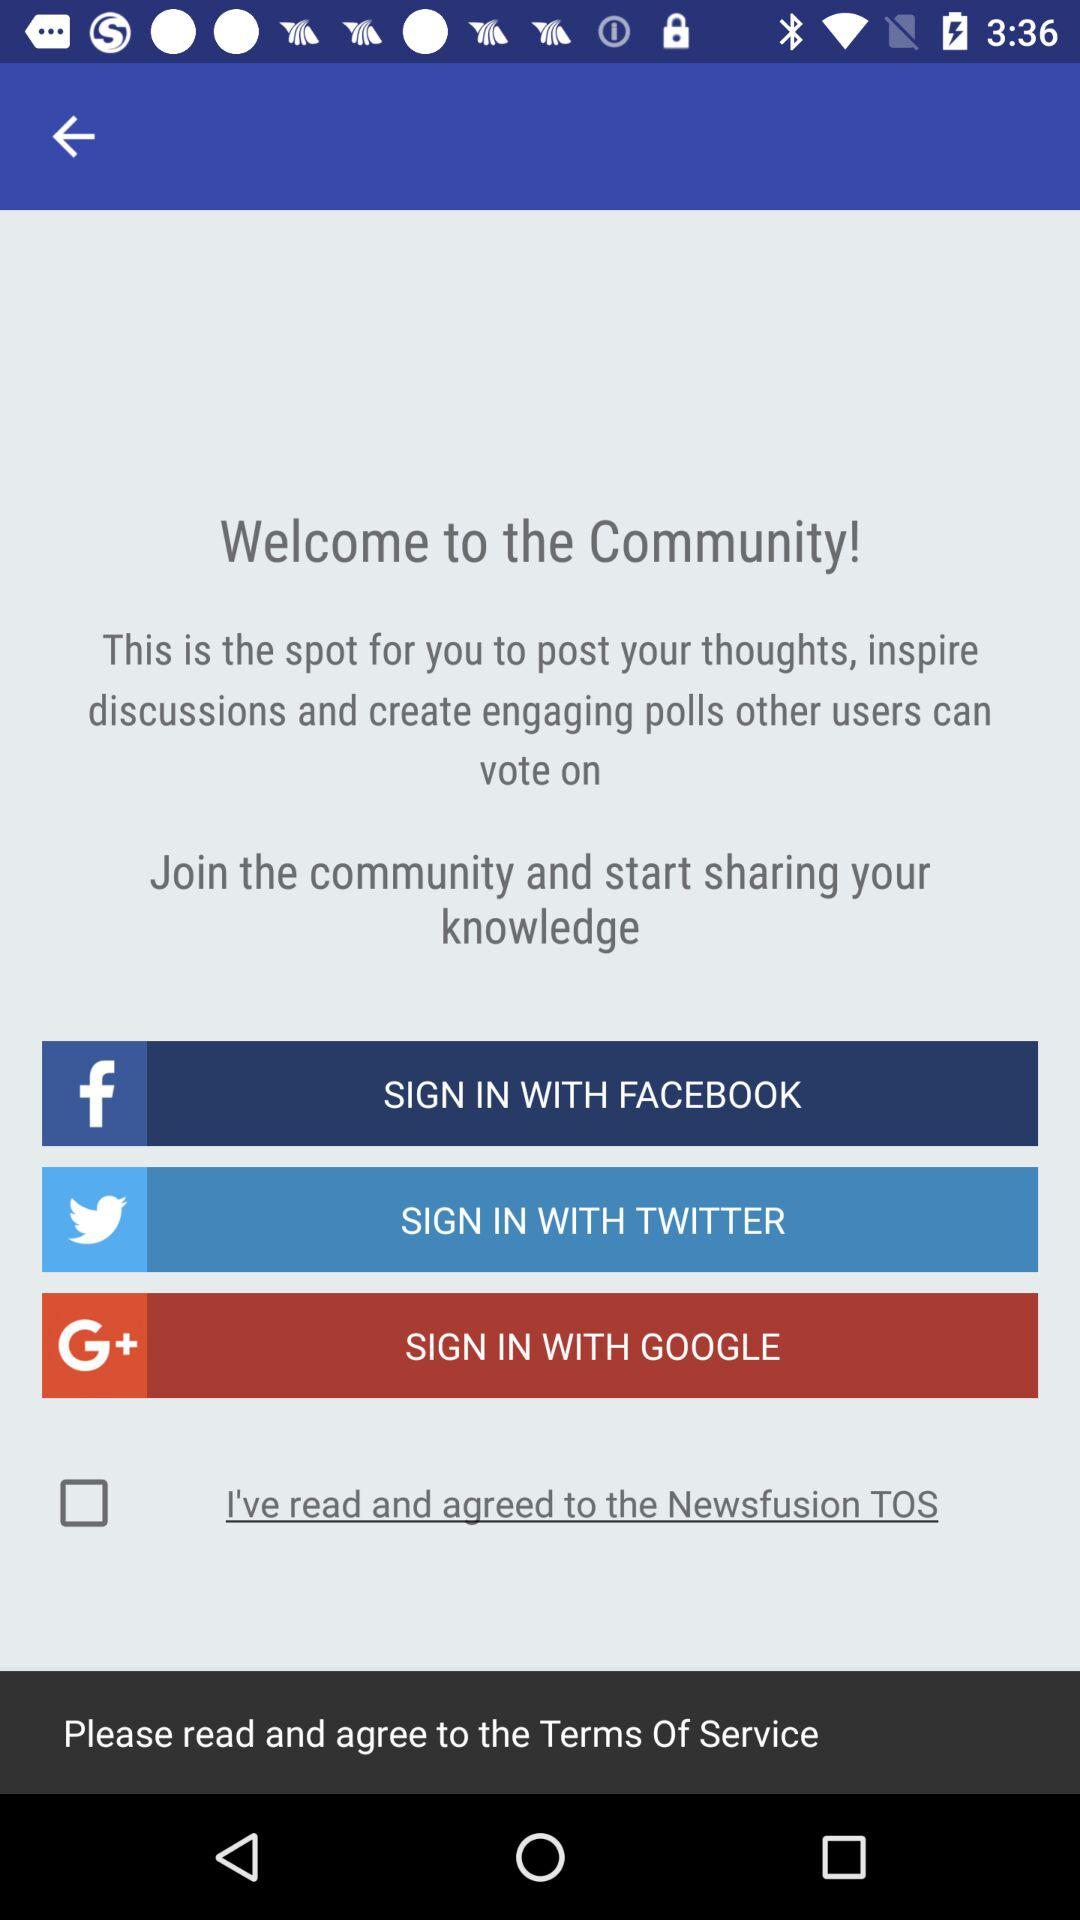Which is the different sign in option? The different sign in options are "FACEBOOK", "TWITTER" and "GOOGLE". 